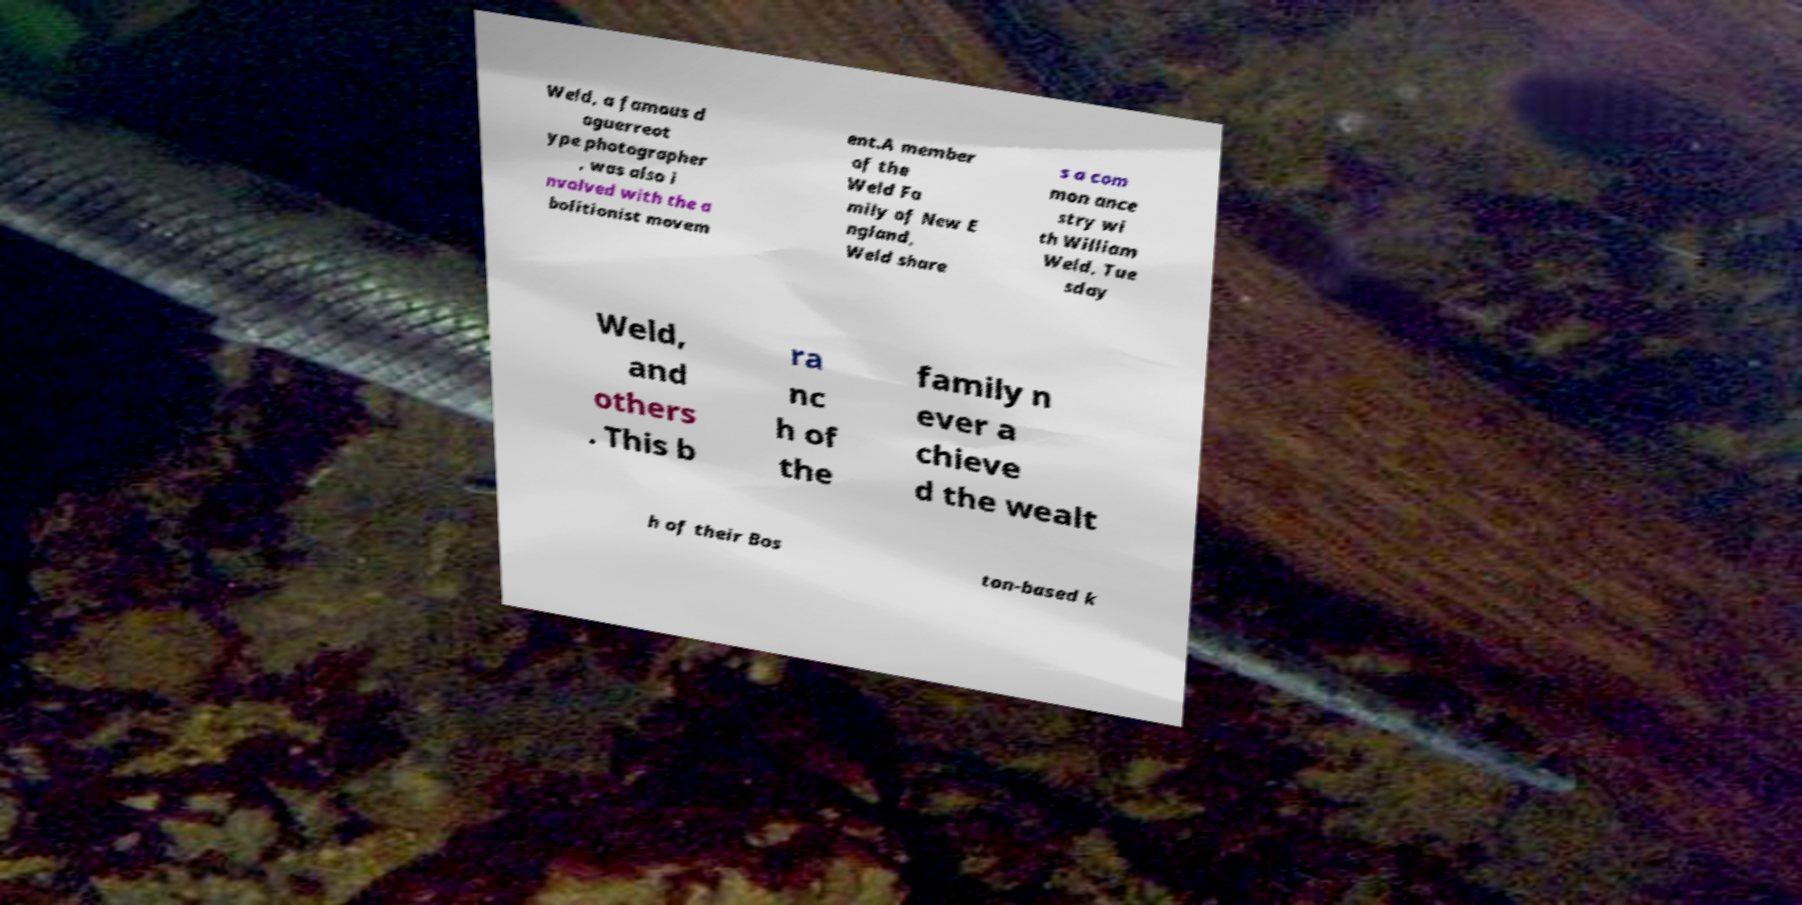Please read and relay the text visible in this image. What does it say? Weld, a famous d aguerreot ype photographer , was also i nvolved with the a bolitionist movem ent.A member of the Weld Fa mily of New E ngland, Weld share s a com mon ance stry wi th William Weld, Tue sday Weld, and others . This b ra nc h of the family n ever a chieve d the wealt h of their Bos ton-based k 